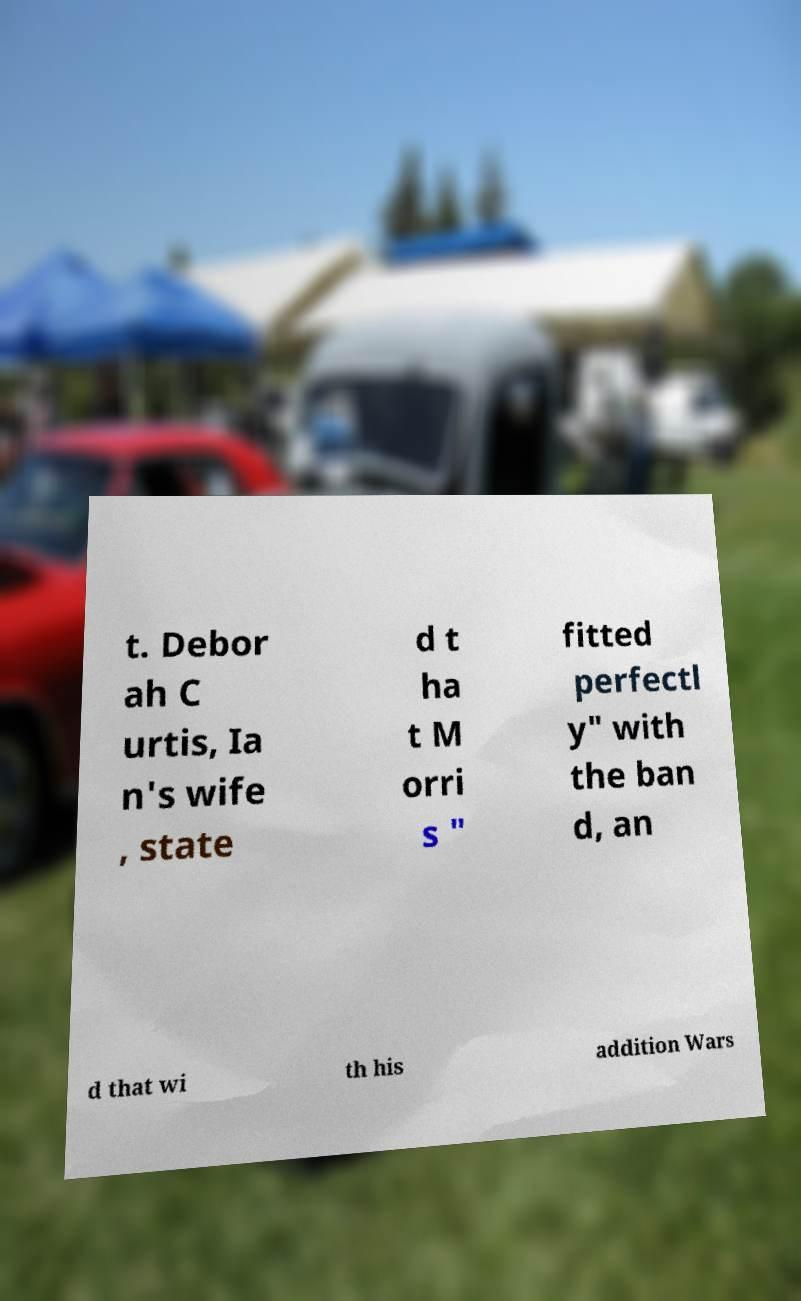There's text embedded in this image that I need extracted. Can you transcribe it verbatim? t. Debor ah C urtis, Ia n's wife , state d t ha t M orri s " fitted perfectl y" with the ban d, an d that wi th his addition Wars 